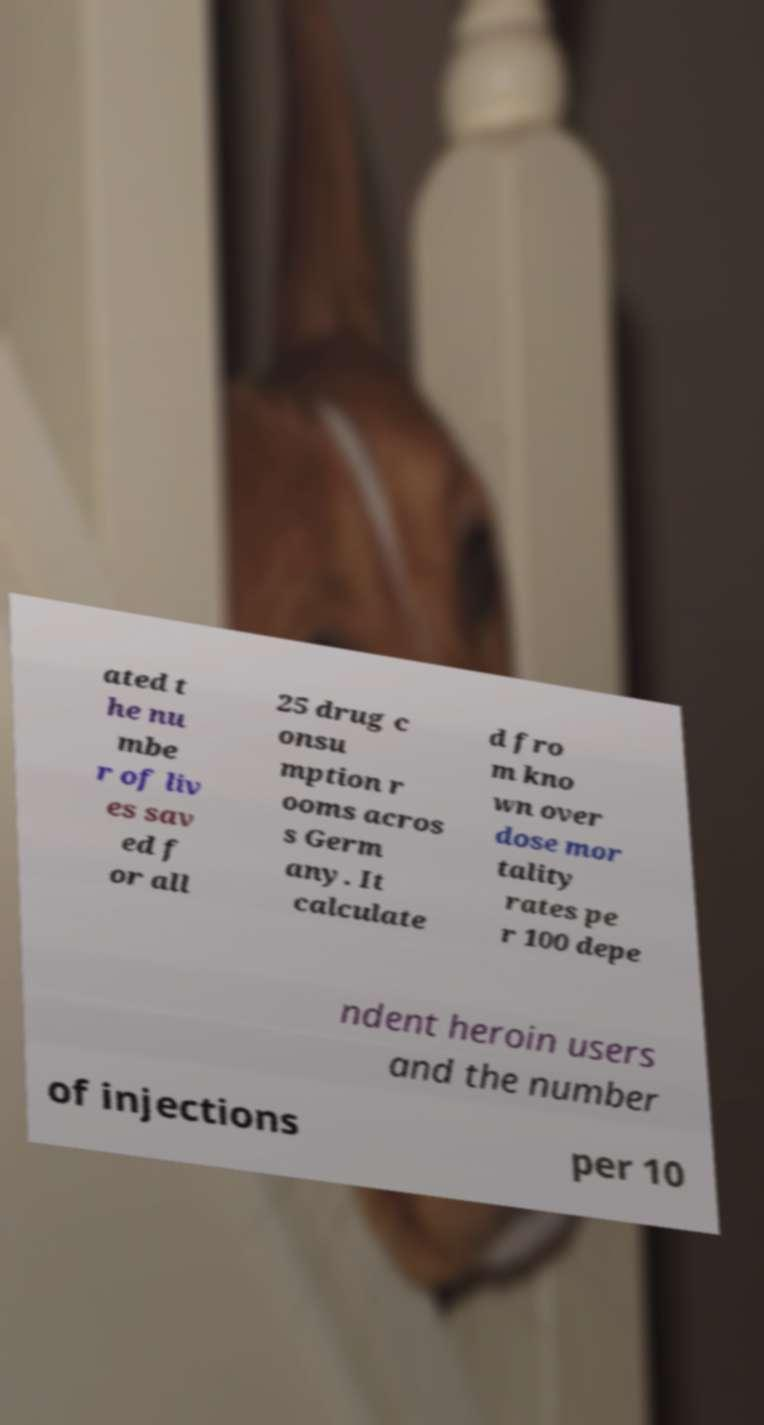Could you assist in decoding the text presented in this image and type it out clearly? ated t he nu mbe r of liv es sav ed f or all 25 drug c onsu mption r ooms acros s Germ any. It calculate d fro m kno wn over dose mor tality rates pe r 100 depe ndent heroin users and the number of injections per 10 